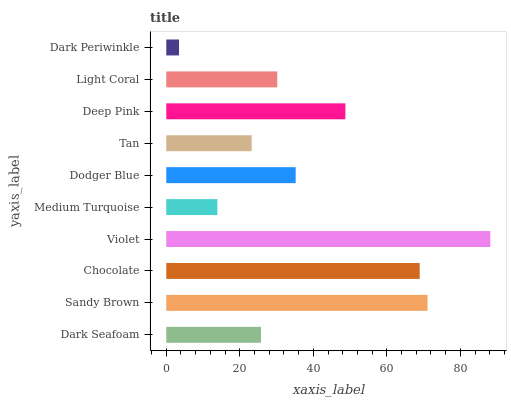Is Dark Periwinkle the minimum?
Answer yes or no. Yes. Is Violet the maximum?
Answer yes or no. Yes. Is Sandy Brown the minimum?
Answer yes or no. No. Is Sandy Brown the maximum?
Answer yes or no. No. Is Sandy Brown greater than Dark Seafoam?
Answer yes or no. Yes. Is Dark Seafoam less than Sandy Brown?
Answer yes or no. Yes. Is Dark Seafoam greater than Sandy Brown?
Answer yes or no. No. Is Sandy Brown less than Dark Seafoam?
Answer yes or no. No. Is Dodger Blue the high median?
Answer yes or no. Yes. Is Light Coral the low median?
Answer yes or no. Yes. Is Medium Turquoise the high median?
Answer yes or no. No. Is Dark Periwinkle the low median?
Answer yes or no. No. 